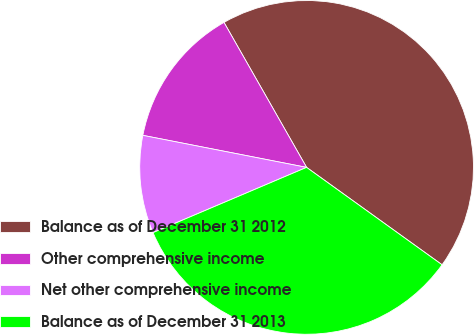Convert chart to OTSL. <chart><loc_0><loc_0><loc_500><loc_500><pie_chart><fcel>Balance as of December 31 2012<fcel>Other comprehensive income<fcel>Net other comprehensive income<fcel>Balance as of December 31 2013<nl><fcel>43.16%<fcel>13.68%<fcel>9.47%<fcel>33.68%<nl></chart> 